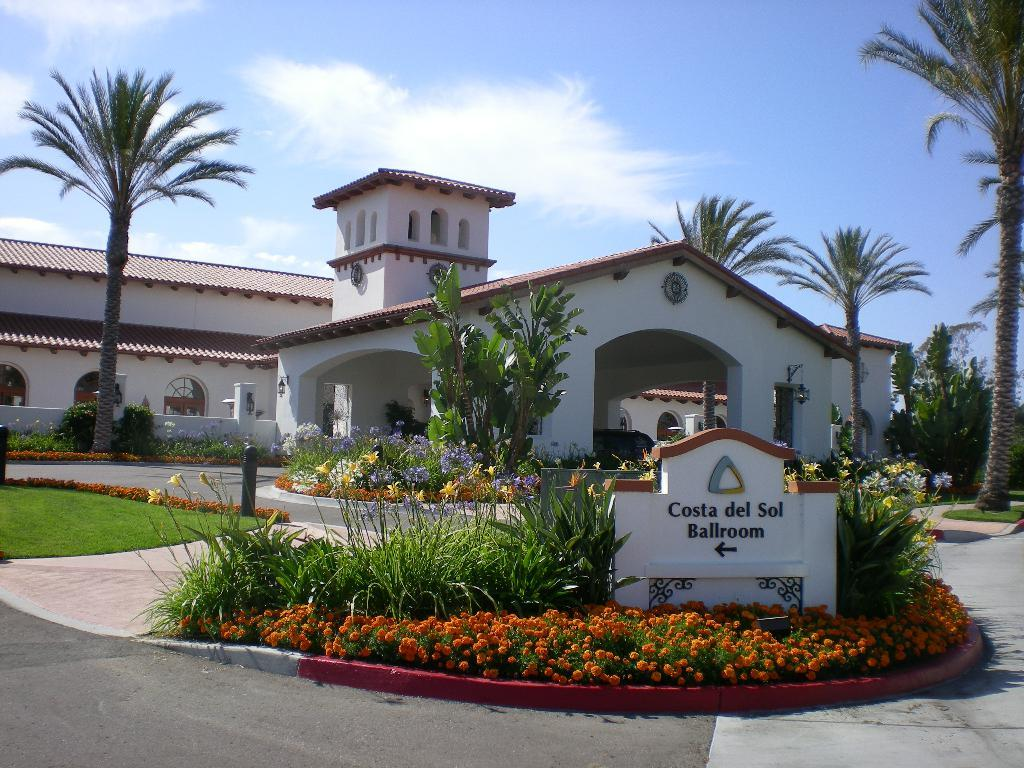What can be seen written on the wall in the image? There is a name on the wall in the image. What type of flora is present in the image? There are flowers, plants, and trees in the image. What is the path made of in the image? The path in the image is made of grass. What type of structure is visible in the image? There is a building with windows in the image. What is visible in the background of the image? The sky is visible in the background of the image, with clouds present. How much sugar is in the pen shown in the image? There is no pen present in the image, and therefore no sugar can be associated with it. 